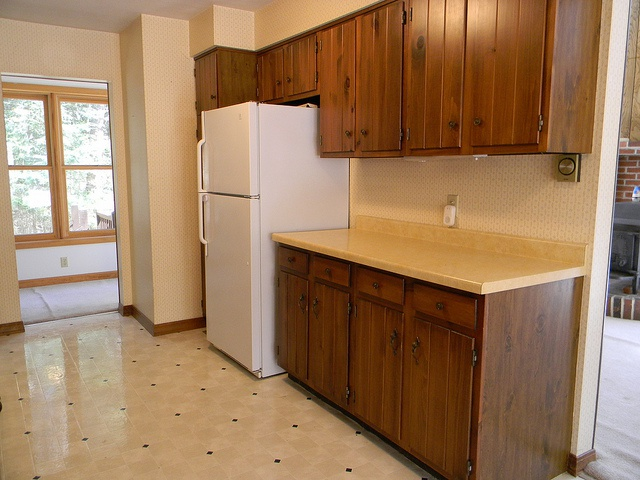Describe the objects in this image and their specific colors. I can see a refrigerator in gray, tan, darkgray, and lightgray tones in this image. 